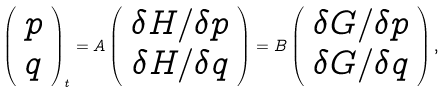<formula> <loc_0><loc_0><loc_500><loc_500>\left ( \begin{array} { c } p \\ q \end{array} \right ) _ { t } = A \left ( \begin{array} { c } \delta H / \delta p \\ \delta H / \delta q \end{array} \right ) = B \left ( \begin{array} { c } \delta G / \delta p \\ \delta G / \delta q \end{array} \right ) ,</formula> 